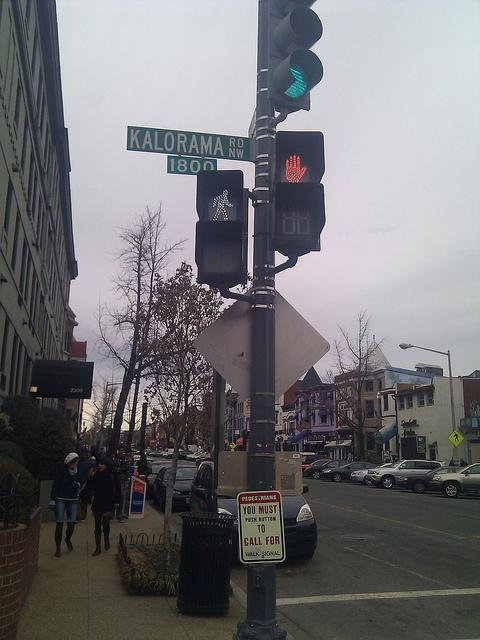The first three letters of the name of the street form the first name of what actor? kal 